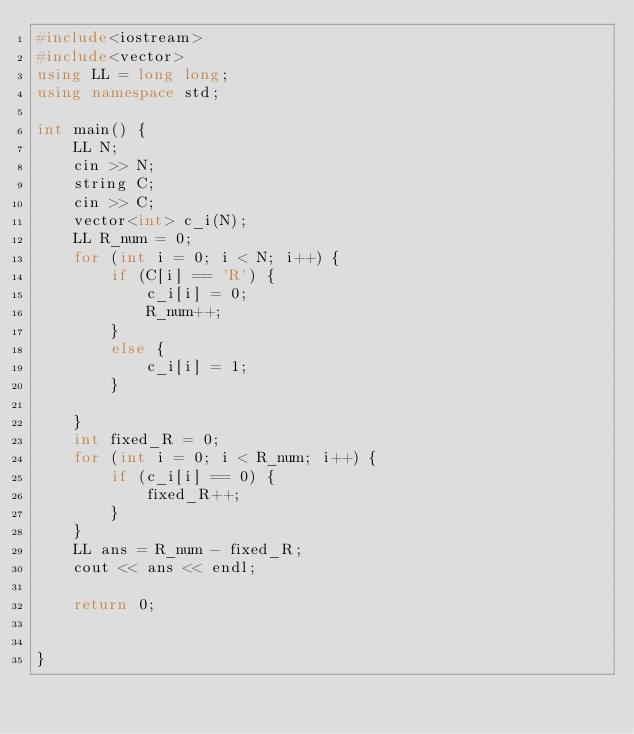Convert code to text. <code><loc_0><loc_0><loc_500><loc_500><_C++_>#include<iostream>
#include<vector>
using LL = long long;
using namespace std;

int main() {
	LL N;
	cin >> N;
	string C;
	cin >> C;
	vector<int> c_i(N);
	LL R_num = 0;
	for (int i = 0; i < N; i++) {
		if (C[i] == 'R') {
			c_i[i] = 0;
			R_num++;
		}
		else {
			c_i[i] = 1;
		}

	}
	int fixed_R = 0;
	for (int i = 0; i < R_num; i++) {
		if (c_i[i] == 0) {
			fixed_R++;
		}
	}
	LL ans = R_num - fixed_R;
	cout << ans << endl;

	return 0;


}</code> 